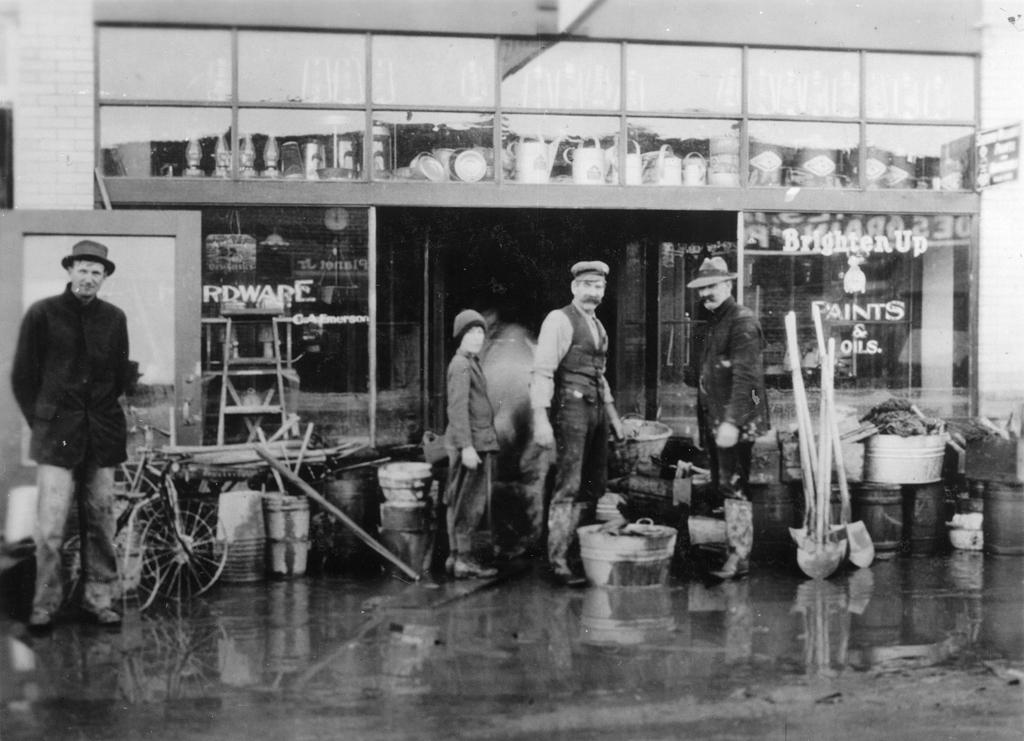How many people are in the image? There are many people in the image. What are the people wearing on their heads? The people are wearing hats and caps. What is at the bottom of the image? There is a floor at the bottom of the image. What can be seen in the background of the image? There is a shop in the background of the image. What type of copper material is being used by the bee in the image? There is no bee or copper material present in the image. 